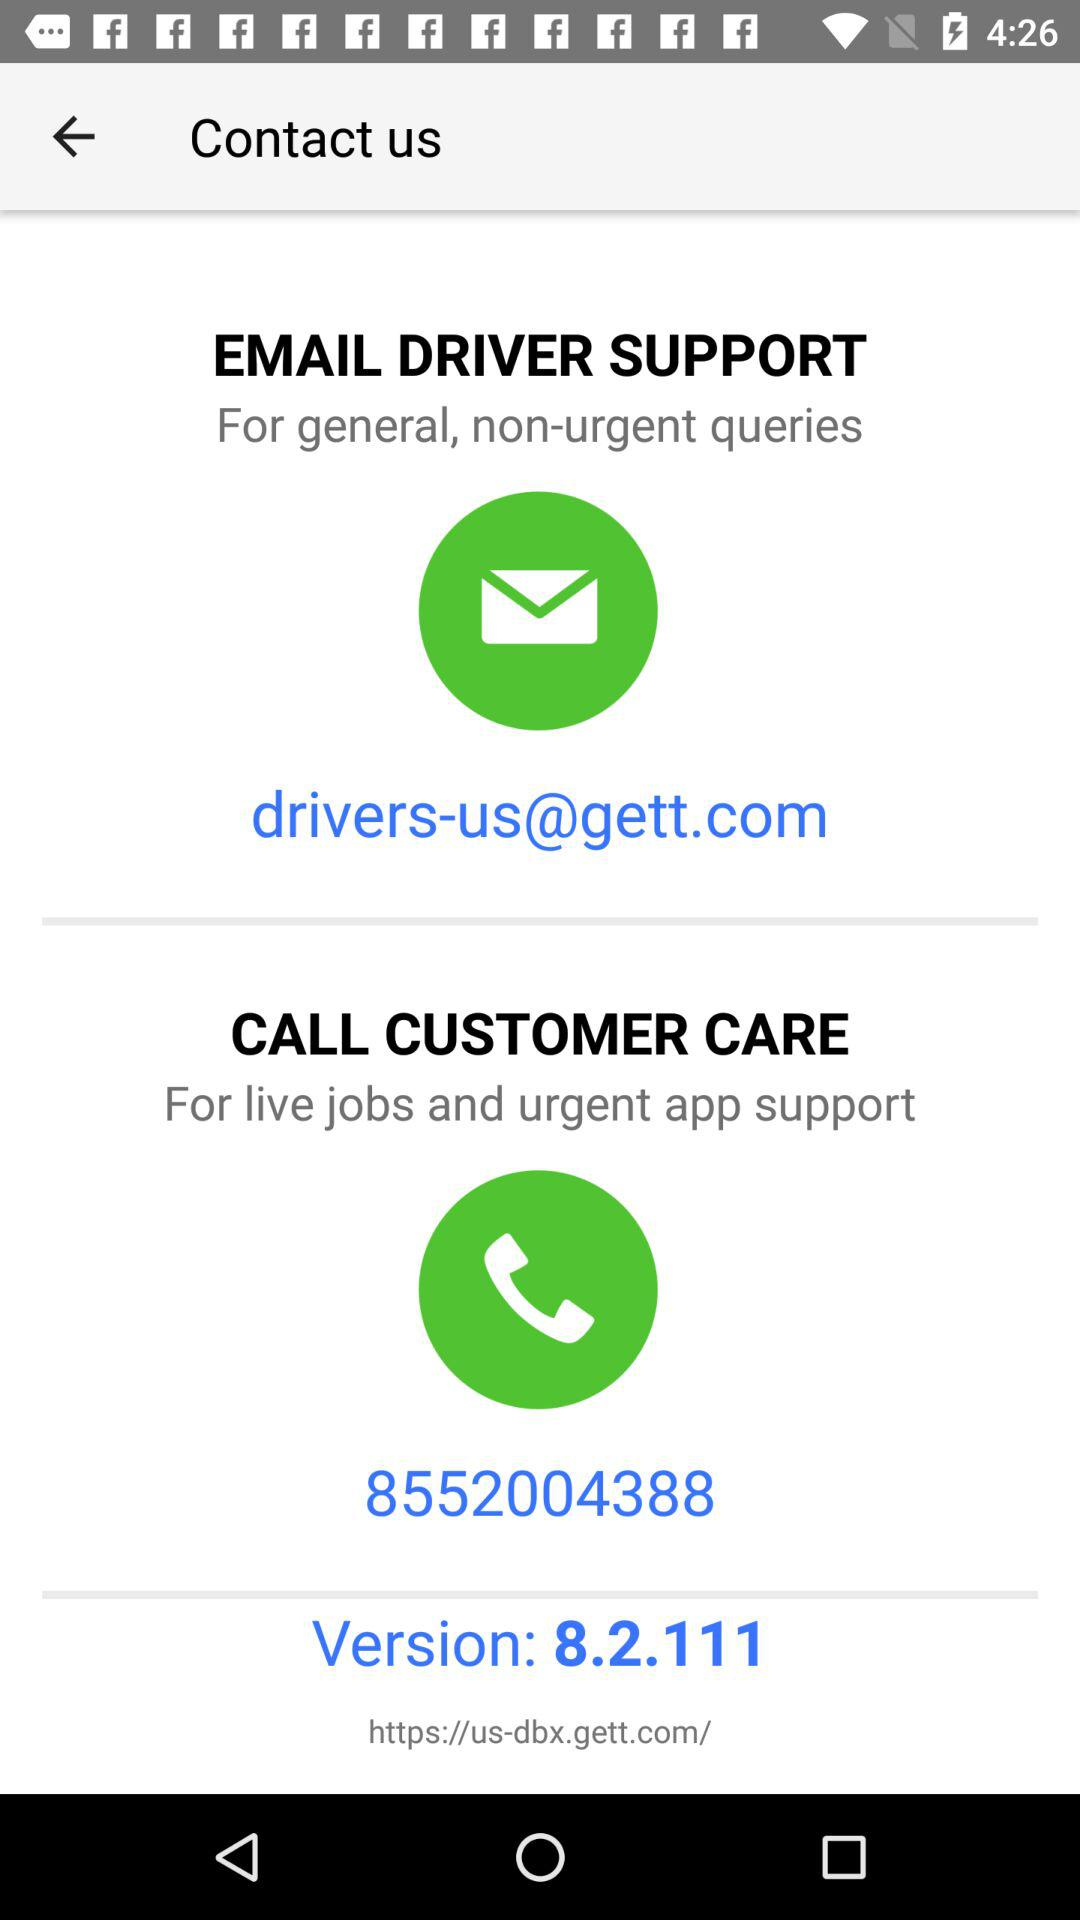What is the customer care number? The customer care number is 8552004388. 